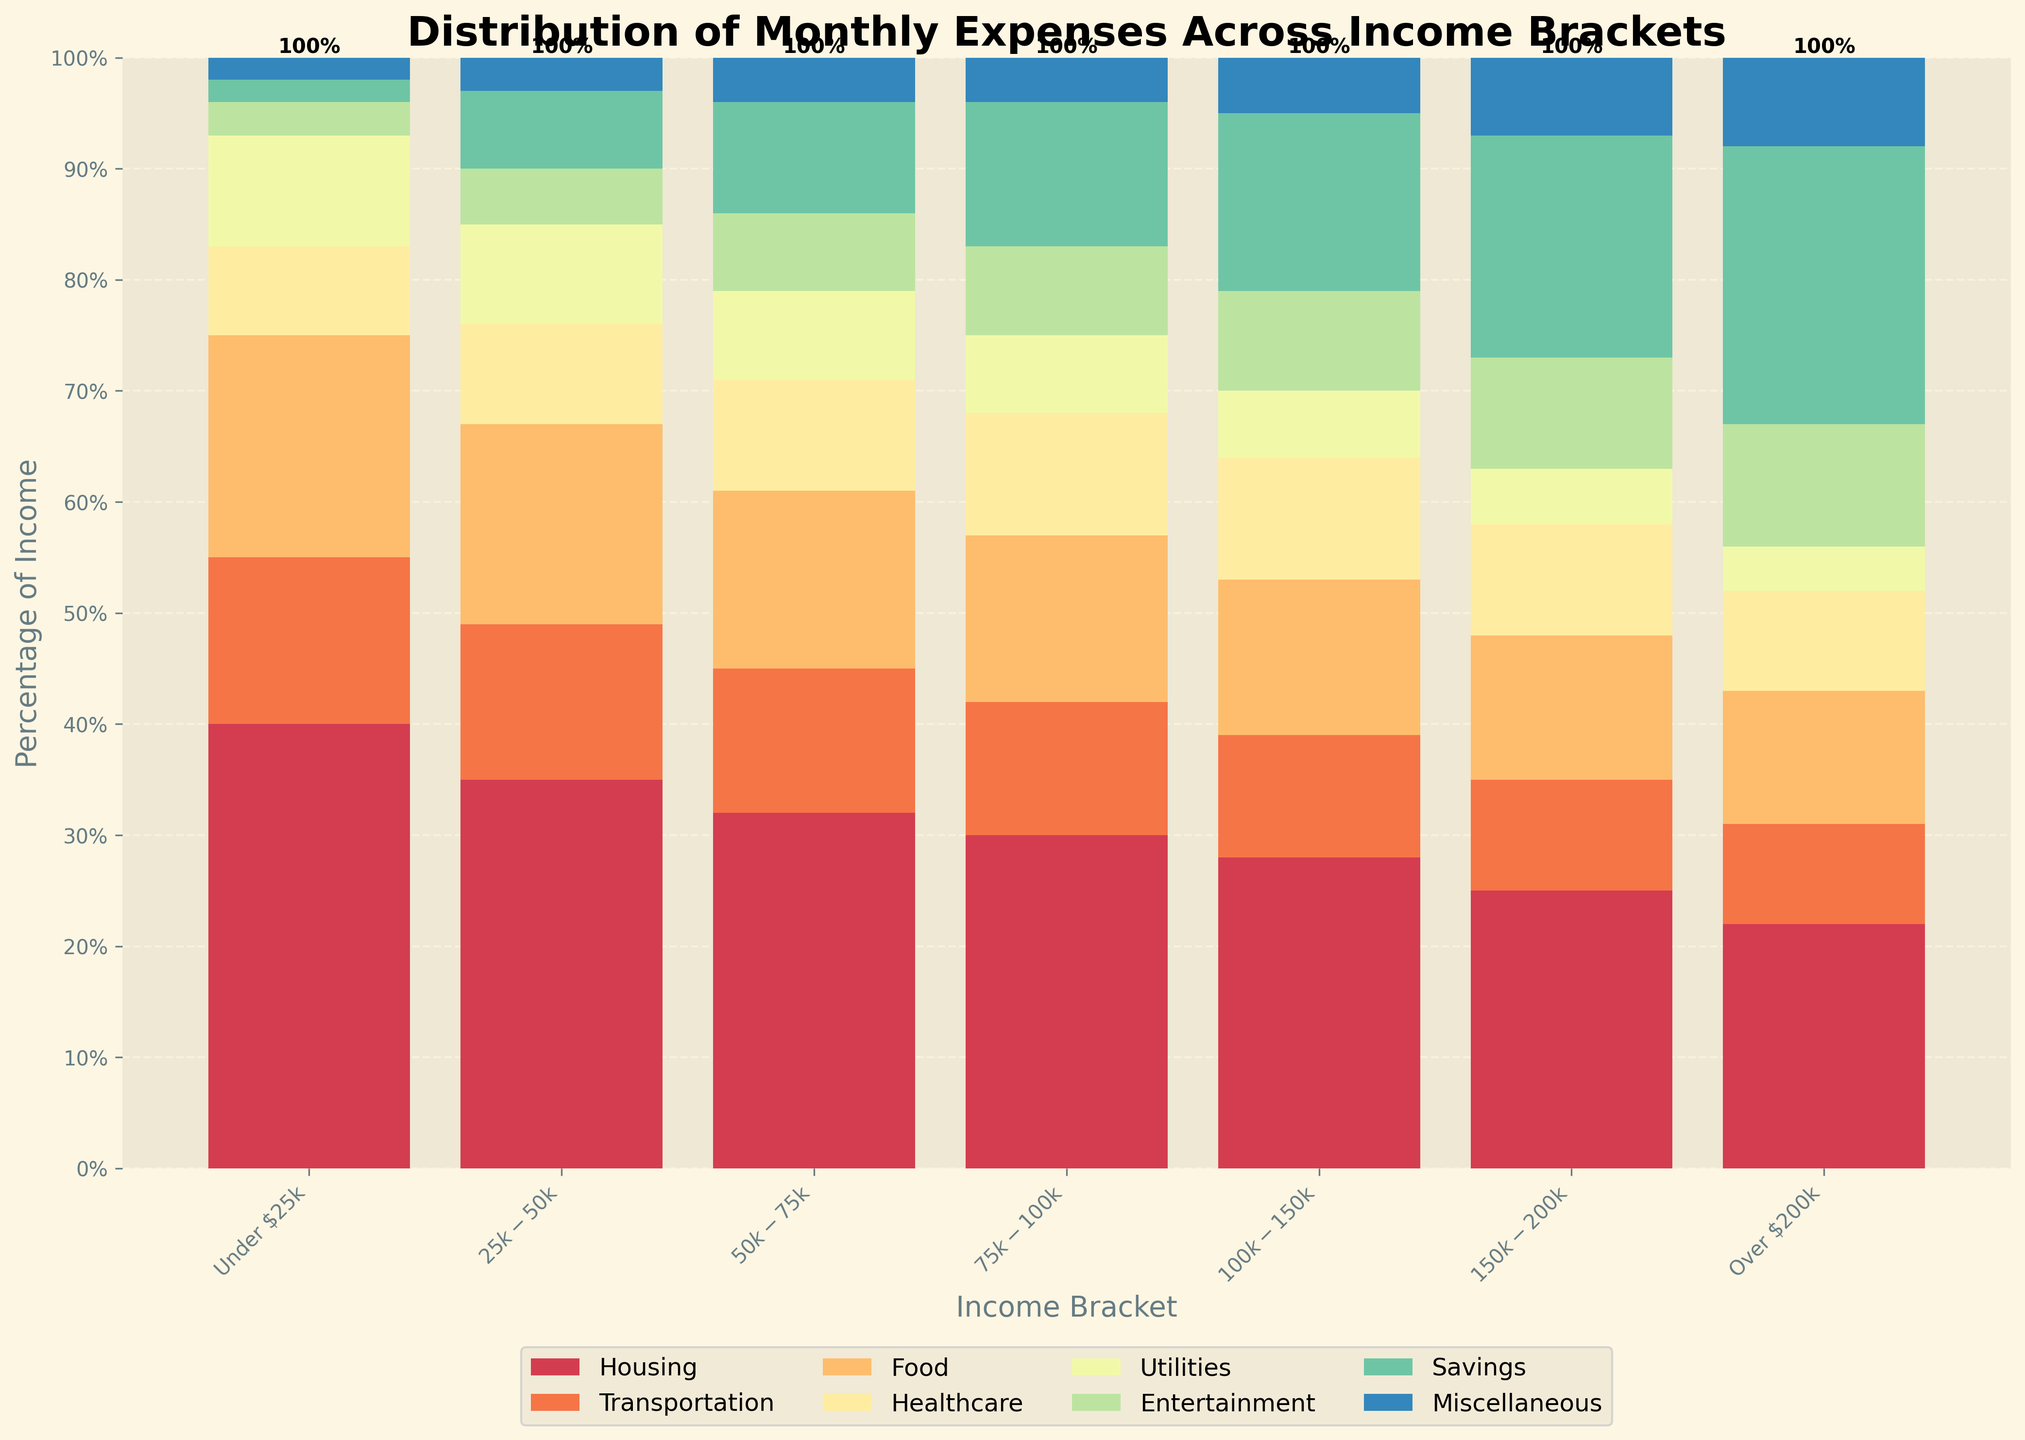Which income bracket has the highest percentage allocated to savings? To find this, look at the "Savings" category across income brackets. The highest percentage is 25% for the "Over $200k" bracket.
Answer: Over $200k What is the total percentage of income allocated to Housing and Food for the "$25k-$50k" income bracket? Sum the percentages for Housing (35%) and Food (18%) under the "$25k-$50k" bracket. 35% + 18% equals 53%.
Answer: 53% How does the percentage allocated to Healthcare change as income increases from "Under $25k" to "Over $200k"? Compare the Healthcare percentages for each income bracket: "Under $25k" (8%), "$25k-$50k" (9%), "$50k-$75k" (10%), "$75k-$100k" (11%), "$100k-$150k" (11%), "$150k-$200k" (10%), "Over $200k" (9%). It's generally increasing and then slightly decreases at the highest bracket.
Answer: Generally increases, then slightly decreases Which income bracket spends the least percentage on Entertainment? Look at the Entertainment category across income brackets. The smallest percentage is 3% for the "Under $25k" bracket.
Answer: Under $25k Is the percentage allocated to Housing greater than the percentage allocated to Food for all income brackets? Compare the percentages of Housing and Food in each bracket. For "Under $25k": Housing (40%) > Food (20%), "$25k-$50k": Housing (35%) > Food (18%), "$50k-$75k": Housing (32%) > Food (16%), "$75k-$100k": Housing (30%) > Food (15%), "$100k-$150k": Housing (28%) > Food (14%), "$150k-$200k": Housing (25%) > Food (13%), "Over $200k": Housing (22%) > Food (12%). For all brackets, Housing is greater than Food.
Answer: Yes What is the difference between the highest and the lowest percentage for the Utilities category? Find the highest percentage for Utilities (10% in "Under $25k") and the lowest (4% in "Over $200k"). The difference is 10% - 4% = 6%.
Answer: 6% In which income bracket is the percentage allocated to Miscellaneous the highest? Identify the Miscellaneous percentages for each income bracket. The highest percentage is 8% for the "Over $200k" bracket.
Answer: Over $200k 